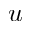Convert formula to latex. <formula><loc_0><loc_0><loc_500><loc_500>u</formula> 